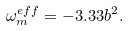<formula> <loc_0><loc_0><loc_500><loc_500>\omega ^ { e f f } _ { m } = - 3 . 3 3 b ^ { 2 } .</formula> 